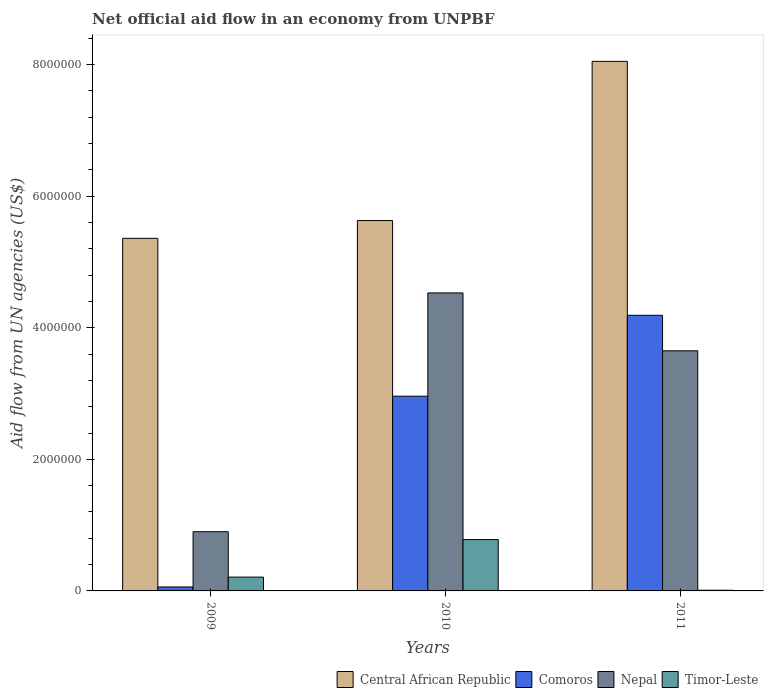Are the number of bars on each tick of the X-axis equal?
Offer a terse response. Yes. How many bars are there on the 3rd tick from the left?
Ensure brevity in your answer.  4. What is the label of the 2nd group of bars from the left?
Ensure brevity in your answer.  2010. In how many cases, is the number of bars for a given year not equal to the number of legend labels?
Make the answer very short. 0. What is the net official aid flow in Timor-Leste in 2010?
Your answer should be compact. 7.80e+05. Across all years, what is the maximum net official aid flow in Nepal?
Your answer should be compact. 4.53e+06. Across all years, what is the minimum net official aid flow in Timor-Leste?
Your response must be concise. 10000. In which year was the net official aid flow in Central African Republic maximum?
Offer a very short reply. 2011. What is the total net official aid flow in Nepal in the graph?
Offer a terse response. 9.08e+06. What is the difference between the net official aid flow in Nepal in 2009 and that in 2011?
Keep it short and to the point. -2.75e+06. What is the difference between the net official aid flow in Nepal in 2011 and the net official aid flow in Timor-Leste in 2010?
Your answer should be compact. 2.87e+06. What is the average net official aid flow in Comoros per year?
Offer a very short reply. 2.40e+06. In the year 2011, what is the difference between the net official aid flow in Nepal and net official aid flow in Central African Republic?
Provide a succinct answer. -4.40e+06. In how many years, is the net official aid flow in Central African Republic greater than 1600000 US$?
Keep it short and to the point. 3. What is the ratio of the net official aid flow in Timor-Leste in 2009 to that in 2010?
Offer a terse response. 0.27. Is the net official aid flow in Timor-Leste in 2009 less than that in 2010?
Give a very brief answer. Yes. Is the difference between the net official aid flow in Nepal in 2009 and 2011 greater than the difference between the net official aid flow in Central African Republic in 2009 and 2011?
Your answer should be compact. No. What is the difference between the highest and the second highest net official aid flow in Nepal?
Keep it short and to the point. 8.80e+05. What is the difference between the highest and the lowest net official aid flow in Central African Republic?
Offer a terse response. 2.69e+06. Is it the case that in every year, the sum of the net official aid flow in Comoros and net official aid flow in Central African Republic is greater than the sum of net official aid flow in Timor-Leste and net official aid flow in Nepal?
Your answer should be compact. No. What does the 3rd bar from the left in 2009 represents?
Make the answer very short. Nepal. What does the 3rd bar from the right in 2011 represents?
Your answer should be very brief. Comoros. How many years are there in the graph?
Your answer should be very brief. 3. Does the graph contain any zero values?
Ensure brevity in your answer.  No. Does the graph contain grids?
Your answer should be compact. No. What is the title of the graph?
Give a very brief answer. Net official aid flow in an economy from UNPBF. What is the label or title of the Y-axis?
Keep it short and to the point. Aid flow from UN agencies (US$). What is the Aid flow from UN agencies (US$) in Central African Republic in 2009?
Provide a short and direct response. 5.36e+06. What is the Aid flow from UN agencies (US$) in Nepal in 2009?
Your answer should be compact. 9.00e+05. What is the Aid flow from UN agencies (US$) of Central African Republic in 2010?
Provide a succinct answer. 5.63e+06. What is the Aid flow from UN agencies (US$) of Comoros in 2010?
Ensure brevity in your answer.  2.96e+06. What is the Aid flow from UN agencies (US$) in Nepal in 2010?
Offer a terse response. 4.53e+06. What is the Aid flow from UN agencies (US$) of Timor-Leste in 2010?
Your answer should be very brief. 7.80e+05. What is the Aid flow from UN agencies (US$) in Central African Republic in 2011?
Give a very brief answer. 8.05e+06. What is the Aid flow from UN agencies (US$) in Comoros in 2011?
Make the answer very short. 4.19e+06. What is the Aid flow from UN agencies (US$) in Nepal in 2011?
Your response must be concise. 3.65e+06. Across all years, what is the maximum Aid flow from UN agencies (US$) in Central African Republic?
Make the answer very short. 8.05e+06. Across all years, what is the maximum Aid flow from UN agencies (US$) of Comoros?
Keep it short and to the point. 4.19e+06. Across all years, what is the maximum Aid flow from UN agencies (US$) of Nepal?
Make the answer very short. 4.53e+06. Across all years, what is the maximum Aid flow from UN agencies (US$) of Timor-Leste?
Your response must be concise. 7.80e+05. Across all years, what is the minimum Aid flow from UN agencies (US$) in Central African Republic?
Offer a terse response. 5.36e+06. Across all years, what is the minimum Aid flow from UN agencies (US$) of Comoros?
Give a very brief answer. 6.00e+04. What is the total Aid flow from UN agencies (US$) in Central African Republic in the graph?
Keep it short and to the point. 1.90e+07. What is the total Aid flow from UN agencies (US$) in Comoros in the graph?
Offer a terse response. 7.21e+06. What is the total Aid flow from UN agencies (US$) of Nepal in the graph?
Ensure brevity in your answer.  9.08e+06. What is the total Aid flow from UN agencies (US$) in Timor-Leste in the graph?
Your response must be concise. 1.00e+06. What is the difference between the Aid flow from UN agencies (US$) in Central African Republic in 2009 and that in 2010?
Your answer should be very brief. -2.70e+05. What is the difference between the Aid flow from UN agencies (US$) in Comoros in 2009 and that in 2010?
Your answer should be compact. -2.90e+06. What is the difference between the Aid flow from UN agencies (US$) of Nepal in 2009 and that in 2010?
Keep it short and to the point. -3.63e+06. What is the difference between the Aid flow from UN agencies (US$) in Timor-Leste in 2009 and that in 2010?
Keep it short and to the point. -5.70e+05. What is the difference between the Aid flow from UN agencies (US$) of Central African Republic in 2009 and that in 2011?
Provide a short and direct response. -2.69e+06. What is the difference between the Aid flow from UN agencies (US$) of Comoros in 2009 and that in 2011?
Offer a very short reply. -4.13e+06. What is the difference between the Aid flow from UN agencies (US$) of Nepal in 2009 and that in 2011?
Make the answer very short. -2.75e+06. What is the difference between the Aid flow from UN agencies (US$) in Central African Republic in 2010 and that in 2011?
Provide a short and direct response. -2.42e+06. What is the difference between the Aid flow from UN agencies (US$) in Comoros in 2010 and that in 2011?
Your answer should be very brief. -1.23e+06. What is the difference between the Aid flow from UN agencies (US$) in Nepal in 2010 and that in 2011?
Provide a short and direct response. 8.80e+05. What is the difference between the Aid flow from UN agencies (US$) in Timor-Leste in 2010 and that in 2011?
Your response must be concise. 7.70e+05. What is the difference between the Aid flow from UN agencies (US$) in Central African Republic in 2009 and the Aid flow from UN agencies (US$) in Comoros in 2010?
Offer a terse response. 2.40e+06. What is the difference between the Aid flow from UN agencies (US$) of Central African Republic in 2009 and the Aid flow from UN agencies (US$) of Nepal in 2010?
Offer a very short reply. 8.30e+05. What is the difference between the Aid flow from UN agencies (US$) in Central African Republic in 2009 and the Aid flow from UN agencies (US$) in Timor-Leste in 2010?
Provide a short and direct response. 4.58e+06. What is the difference between the Aid flow from UN agencies (US$) of Comoros in 2009 and the Aid flow from UN agencies (US$) of Nepal in 2010?
Keep it short and to the point. -4.47e+06. What is the difference between the Aid flow from UN agencies (US$) of Comoros in 2009 and the Aid flow from UN agencies (US$) of Timor-Leste in 2010?
Ensure brevity in your answer.  -7.20e+05. What is the difference between the Aid flow from UN agencies (US$) of Nepal in 2009 and the Aid flow from UN agencies (US$) of Timor-Leste in 2010?
Provide a short and direct response. 1.20e+05. What is the difference between the Aid flow from UN agencies (US$) in Central African Republic in 2009 and the Aid flow from UN agencies (US$) in Comoros in 2011?
Offer a terse response. 1.17e+06. What is the difference between the Aid flow from UN agencies (US$) in Central African Republic in 2009 and the Aid flow from UN agencies (US$) in Nepal in 2011?
Offer a terse response. 1.71e+06. What is the difference between the Aid flow from UN agencies (US$) of Central African Republic in 2009 and the Aid flow from UN agencies (US$) of Timor-Leste in 2011?
Your response must be concise. 5.35e+06. What is the difference between the Aid flow from UN agencies (US$) in Comoros in 2009 and the Aid flow from UN agencies (US$) in Nepal in 2011?
Provide a short and direct response. -3.59e+06. What is the difference between the Aid flow from UN agencies (US$) of Nepal in 2009 and the Aid flow from UN agencies (US$) of Timor-Leste in 2011?
Provide a succinct answer. 8.90e+05. What is the difference between the Aid flow from UN agencies (US$) of Central African Republic in 2010 and the Aid flow from UN agencies (US$) of Comoros in 2011?
Make the answer very short. 1.44e+06. What is the difference between the Aid flow from UN agencies (US$) of Central African Republic in 2010 and the Aid flow from UN agencies (US$) of Nepal in 2011?
Make the answer very short. 1.98e+06. What is the difference between the Aid flow from UN agencies (US$) in Central African Republic in 2010 and the Aid flow from UN agencies (US$) in Timor-Leste in 2011?
Your answer should be compact. 5.62e+06. What is the difference between the Aid flow from UN agencies (US$) in Comoros in 2010 and the Aid flow from UN agencies (US$) in Nepal in 2011?
Offer a terse response. -6.90e+05. What is the difference between the Aid flow from UN agencies (US$) in Comoros in 2010 and the Aid flow from UN agencies (US$) in Timor-Leste in 2011?
Offer a very short reply. 2.95e+06. What is the difference between the Aid flow from UN agencies (US$) in Nepal in 2010 and the Aid flow from UN agencies (US$) in Timor-Leste in 2011?
Offer a very short reply. 4.52e+06. What is the average Aid flow from UN agencies (US$) of Central African Republic per year?
Your response must be concise. 6.35e+06. What is the average Aid flow from UN agencies (US$) of Comoros per year?
Your answer should be very brief. 2.40e+06. What is the average Aid flow from UN agencies (US$) of Nepal per year?
Your answer should be very brief. 3.03e+06. What is the average Aid flow from UN agencies (US$) of Timor-Leste per year?
Your answer should be very brief. 3.33e+05. In the year 2009, what is the difference between the Aid flow from UN agencies (US$) of Central African Republic and Aid flow from UN agencies (US$) of Comoros?
Offer a very short reply. 5.30e+06. In the year 2009, what is the difference between the Aid flow from UN agencies (US$) in Central African Republic and Aid flow from UN agencies (US$) in Nepal?
Provide a succinct answer. 4.46e+06. In the year 2009, what is the difference between the Aid flow from UN agencies (US$) in Central African Republic and Aid flow from UN agencies (US$) in Timor-Leste?
Provide a succinct answer. 5.15e+06. In the year 2009, what is the difference between the Aid flow from UN agencies (US$) of Comoros and Aid flow from UN agencies (US$) of Nepal?
Ensure brevity in your answer.  -8.40e+05. In the year 2009, what is the difference between the Aid flow from UN agencies (US$) of Comoros and Aid flow from UN agencies (US$) of Timor-Leste?
Keep it short and to the point. -1.50e+05. In the year 2009, what is the difference between the Aid flow from UN agencies (US$) in Nepal and Aid flow from UN agencies (US$) in Timor-Leste?
Make the answer very short. 6.90e+05. In the year 2010, what is the difference between the Aid flow from UN agencies (US$) of Central African Republic and Aid flow from UN agencies (US$) of Comoros?
Your answer should be compact. 2.67e+06. In the year 2010, what is the difference between the Aid flow from UN agencies (US$) of Central African Republic and Aid flow from UN agencies (US$) of Nepal?
Provide a short and direct response. 1.10e+06. In the year 2010, what is the difference between the Aid flow from UN agencies (US$) of Central African Republic and Aid flow from UN agencies (US$) of Timor-Leste?
Offer a terse response. 4.85e+06. In the year 2010, what is the difference between the Aid flow from UN agencies (US$) in Comoros and Aid flow from UN agencies (US$) in Nepal?
Give a very brief answer. -1.57e+06. In the year 2010, what is the difference between the Aid flow from UN agencies (US$) in Comoros and Aid flow from UN agencies (US$) in Timor-Leste?
Your answer should be very brief. 2.18e+06. In the year 2010, what is the difference between the Aid flow from UN agencies (US$) in Nepal and Aid flow from UN agencies (US$) in Timor-Leste?
Your answer should be very brief. 3.75e+06. In the year 2011, what is the difference between the Aid flow from UN agencies (US$) of Central African Republic and Aid flow from UN agencies (US$) of Comoros?
Make the answer very short. 3.86e+06. In the year 2011, what is the difference between the Aid flow from UN agencies (US$) in Central African Republic and Aid flow from UN agencies (US$) in Nepal?
Provide a succinct answer. 4.40e+06. In the year 2011, what is the difference between the Aid flow from UN agencies (US$) of Central African Republic and Aid flow from UN agencies (US$) of Timor-Leste?
Offer a very short reply. 8.04e+06. In the year 2011, what is the difference between the Aid flow from UN agencies (US$) in Comoros and Aid flow from UN agencies (US$) in Nepal?
Provide a succinct answer. 5.40e+05. In the year 2011, what is the difference between the Aid flow from UN agencies (US$) of Comoros and Aid flow from UN agencies (US$) of Timor-Leste?
Your answer should be very brief. 4.18e+06. In the year 2011, what is the difference between the Aid flow from UN agencies (US$) in Nepal and Aid flow from UN agencies (US$) in Timor-Leste?
Provide a short and direct response. 3.64e+06. What is the ratio of the Aid flow from UN agencies (US$) in Central African Republic in 2009 to that in 2010?
Offer a very short reply. 0.95. What is the ratio of the Aid flow from UN agencies (US$) of Comoros in 2009 to that in 2010?
Provide a short and direct response. 0.02. What is the ratio of the Aid flow from UN agencies (US$) in Nepal in 2009 to that in 2010?
Provide a short and direct response. 0.2. What is the ratio of the Aid flow from UN agencies (US$) of Timor-Leste in 2009 to that in 2010?
Keep it short and to the point. 0.27. What is the ratio of the Aid flow from UN agencies (US$) of Central African Republic in 2009 to that in 2011?
Provide a succinct answer. 0.67. What is the ratio of the Aid flow from UN agencies (US$) in Comoros in 2009 to that in 2011?
Provide a succinct answer. 0.01. What is the ratio of the Aid flow from UN agencies (US$) of Nepal in 2009 to that in 2011?
Ensure brevity in your answer.  0.25. What is the ratio of the Aid flow from UN agencies (US$) of Timor-Leste in 2009 to that in 2011?
Keep it short and to the point. 21. What is the ratio of the Aid flow from UN agencies (US$) in Central African Republic in 2010 to that in 2011?
Keep it short and to the point. 0.7. What is the ratio of the Aid flow from UN agencies (US$) of Comoros in 2010 to that in 2011?
Give a very brief answer. 0.71. What is the ratio of the Aid flow from UN agencies (US$) of Nepal in 2010 to that in 2011?
Offer a terse response. 1.24. What is the difference between the highest and the second highest Aid flow from UN agencies (US$) in Central African Republic?
Offer a terse response. 2.42e+06. What is the difference between the highest and the second highest Aid flow from UN agencies (US$) in Comoros?
Ensure brevity in your answer.  1.23e+06. What is the difference between the highest and the second highest Aid flow from UN agencies (US$) in Nepal?
Your answer should be very brief. 8.80e+05. What is the difference between the highest and the second highest Aid flow from UN agencies (US$) in Timor-Leste?
Ensure brevity in your answer.  5.70e+05. What is the difference between the highest and the lowest Aid flow from UN agencies (US$) in Central African Republic?
Make the answer very short. 2.69e+06. What is the difference between the highest and the lowest Aid flow from UN agencies (US$) of Comoros?
Your response must be concise. 4.13e+06. What is the difference between the highest and the lowest Aid flow from UN agencies (US$) in Nepal?
Your answer should be very brief. 3.63e+06. What is the difference between the highest and the lowest Aid flow from UN agencies (US$) of Timor-Leste?
Make the answer very short. 7.70e+05. 